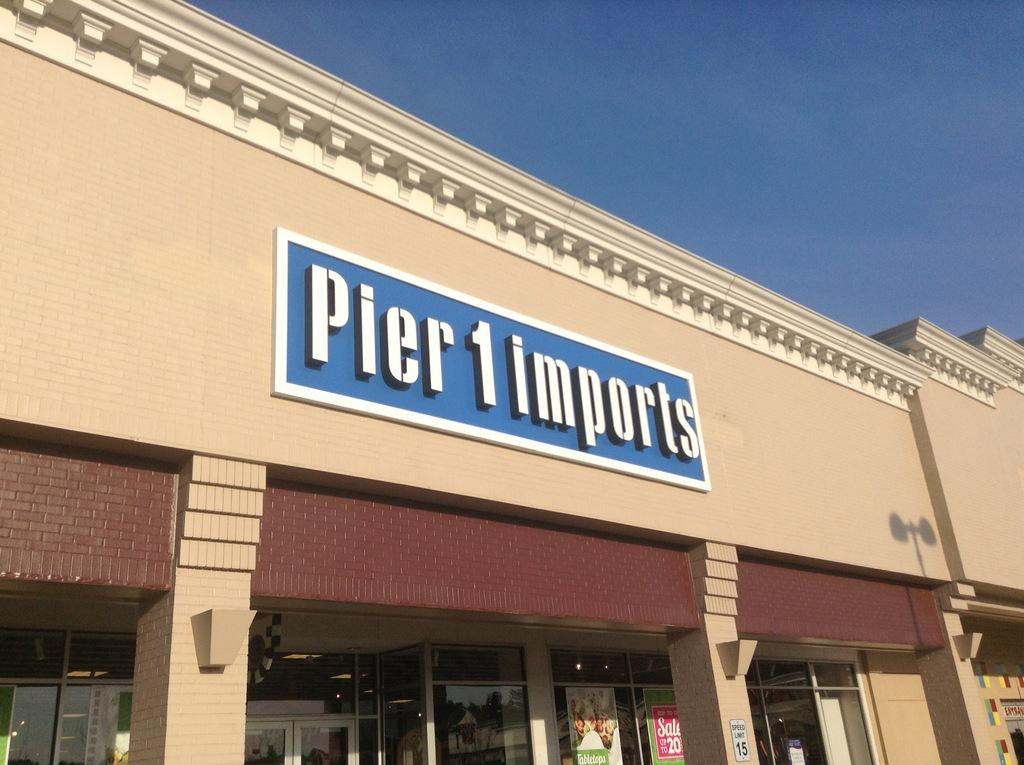What is the main structure in the picture? There is a building in the picture. What is located in the center of the picture? There is a board in the center of the picture. What is present at the bottom of the picture? There are banners at the bottom of the picture. What type of windows are visible in the picture? There are glass windows in the picture. Are there any entrances visible in the picture? Yes, there are doors in the picture. How would you describe the weather based on the image? The sky is sunny in the picture. What type of grape is being used as a base for the building in the image? There is no grape present in the image, and grapes are not used as a base for buildings. 